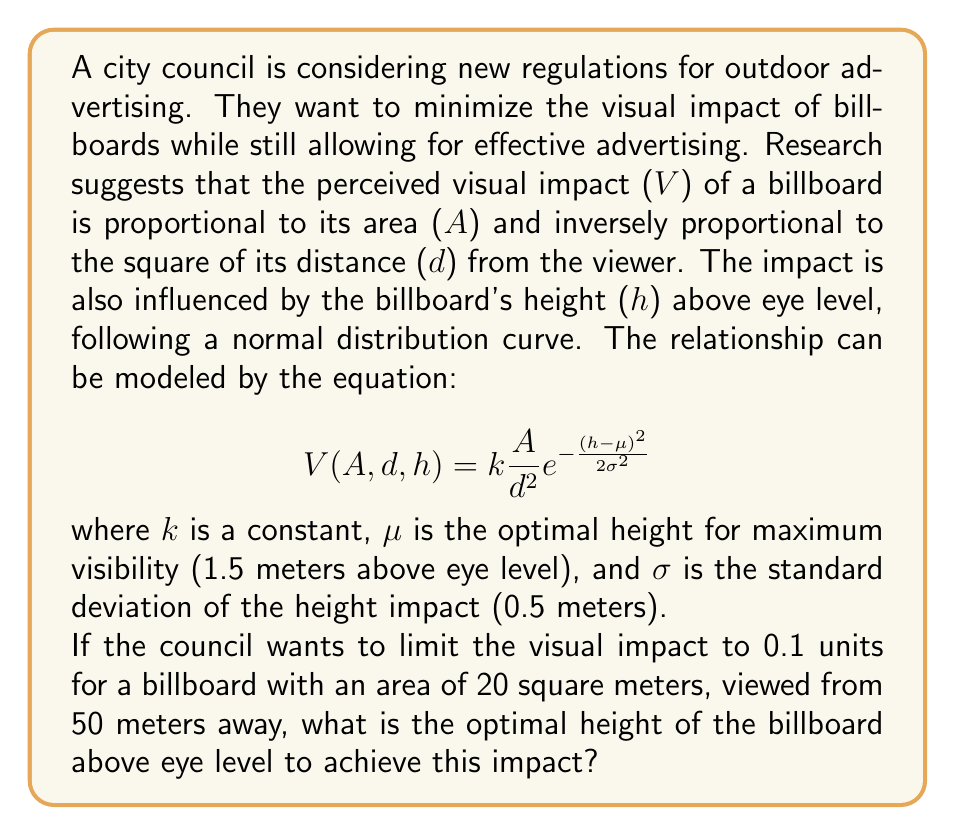What is the answer to this math problem? To solve this problem, we need to follow these steps:

1) We start with the given equation:
   $$V(A,d,h) = k\frac{A}{d^2}e^{-\frac{(h-\mu)^2}{2\sigma^2}}$$

2) We're given that:
   V = 0.1 (desired visual impact)
   A = 20 m² (area of the billboard)
   d = 50 m (distance from the viewer)
   μ = 1.5 m (optimal height for maximum visibility)
   σ = 0.5 m (standard deviation of height impact)

3) We need to solve for h. Let's substitute the known values:

   $$0.1 = k\frac{20}{50^2}e^{-\frac{(h-1.5)^2}{2(0.5)^2}}$$

4) Simplify:
   $$0.1 = k\frac{1}{125}e^{-\frac{(h-1.5)^2}{0.5}}$$

5) We don't know k, but we can eliminate it by dividing both sides by $k\frac{1}{125}$:

   $$12.5 = e^{-\frac{(h-1.5)^2}{0.5}}$$

6) Take the natural log of both sides:

   $$\ln(12.5) = -\frac{(h-1.5)^2}{0.5}$$

7) Multiply both sides by -0.5:

   $$-0.5\ln(12.5) = (h-1.5)^2$$

8) Take the square root of both sides:

   $$\sqrt{-0.5\ln(12.5)} = |h-1.5|$$

9) Solve for h:

   $$h = 1.5 \pm \sqrt{-0.5\ln(12.5)}$$

10) Calculate the value:

    $$h \approx 1.5 \pm 1.26$$

11) This gives us two possible solutions: h ≈ 2.76 m or h ≈ 0.24 m above eye level.

12) Since we're looking for the optimal height to minimize impact, and we know the impact follows a normal distribution centered at 1.5 m, we choose the value closer to 1.5 m.
Answer: 2.76 meters above eye level 